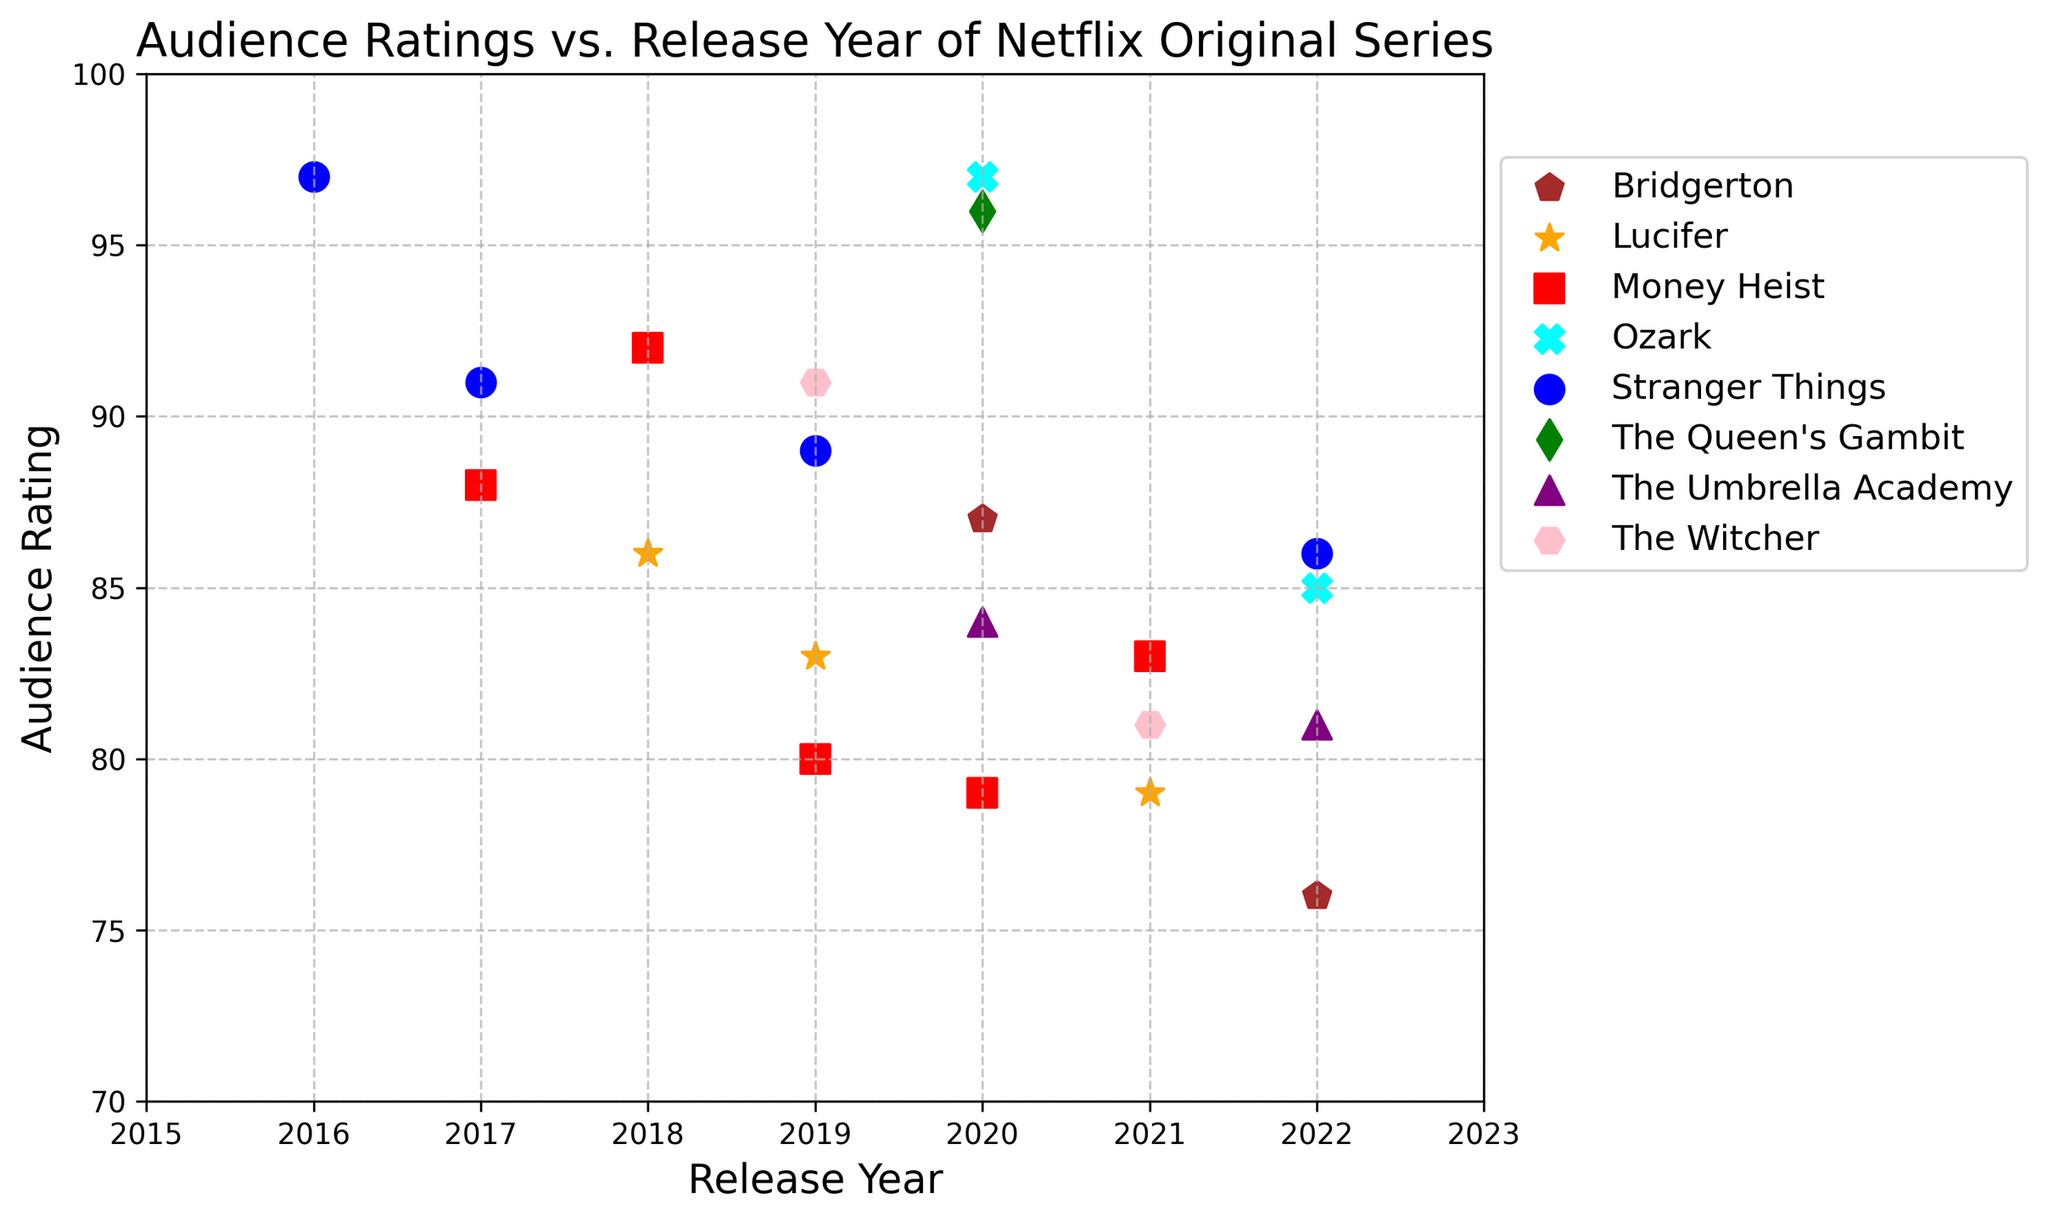what is the highest audience rating for "Stranger Things"? To find the highest audience rating for "Stranger Things," look at all the rating points for this series in the scatter plot. The ratings are 97, 91, 89, and 86. The highest among these is 97.
Answer: 97 Which show has the lowest audience rating in 2020? To determine the show with the lowest audience rating in 2020, identify all the data points for 2020 and compare their ratings. The shows from 2020 are "Money Heist" with 79, "The Queen's Gambit" with 96, "The Umbrella Academy" with 84, "Bridgerton" with 87, and "Ozark" with 97. The lowest rating among these is 79 for "Money Heist."
Answer: Money Heist For which series does the audience rating drop highest between two consecutive seasons? To find this, you need to examine the difference in audience ratings between consecutive seasons for each series and determine the highest drop. For "Stranger Things," the highest drop is (97-91)=6, for "Money Heist" it is (92-80)=12, for "Lucifer" it is (83-79)=4, for "Bridgerton" it is (87-76)=11, for "The Witcher" it is (91-81)=10, and for "Ozark" it is (97-85)=12. The highest drops of 12 are for both "Money Heist" and "Ozark".
Answer: Money Heist & Ozark Which series has the highest average audience rating across all seasons? To determine this, calculate the average rating of each series across all its seasons. "Stranger Things": (97+91+89+86)/4 = 90.75, "Money Heist": (88+92+80+79+83)/5 = 84.4, "The Queen's Gambit": 96, "The Umbrella Academy": (84+81)/2 = 82.5, "Lucifer": (86+83+79)/3 = 82.67, "Bridgerton": (87+76)/2 = 81.5, "The Witcher": (91+81)/2 = 86, "Ozark": (97+85)/2 = 91. The highest average rating is for "The Queen's Gambit" at 96 followed by "Ozark" at 91.
Answer: The Queen's Gambit What is the difference in audience rating between the first season of "Money Heist" and the first season of "Bridgerton"? Look at the audience ratings for the first seasons of "Money Heist" and "Bridgerton." The rating for "Money Heist" Season 1 is 88, and for "Bridgerton" Season 1 it is 87. The difference between these two ratings is
Answer: 88 - 87 = 1 How does the audience rating of "Stranger Things" change from season to season? To evaluate the change, look at the rating progression for each season of "Stranger Things." The audience ratings are 97 for Season 1, 91 for Season 2, 89 for Season 3, and 86 for Season 4. From Season 1 to 2, the change is (97-91)=-6, from Season 2 to 3 is (91-89)=-2, and from Season 3 to 4 is (89-86)=-3. So, the ratings decline step-by-step.
Answer: Declines each season 